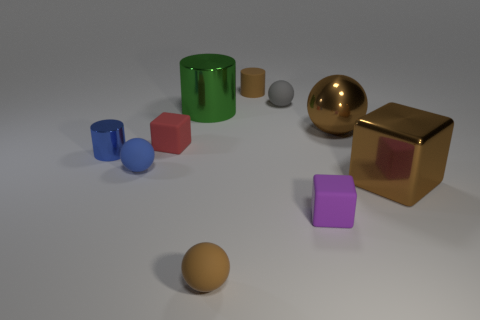Are there fewer big shiny balls in front of the gray rubber thing than large shiny spheres behind the blue cylinder?
Your answer should be compact. No. There is a brown object that is in front of the tiny gray matte object and left of the small gray sphere; what shape is it?
Your answer should be very brief. Sphere. How many other big objects are the same shape as the red object?
Give a very brief answer. 1. There is a red object that is made of the same material as the small gray sphere; what is its size?
Offer a very short reply. Small. Are there more brown rubber objects than tiny blue rubber blocks?
Ensure brevity in your answer.  Yes. There is a tiny cube in front of the tiny blue sphere; what is its color?
Your response must be concise. Purple. There is a thing that is on the left side of the red thing and behind the tiny blue matte thing; how big is it?
Your response must be concise. Small. What number of purple rubber objects have the same size as the green cylinder?
Offer a very short reply. 0. What material is the red object that is the same shape as the purple rubber object?
Make the answer very short. Rubber. Do the tiny red thing and the small metal thing have the same shape?
Your answer should be very brief. No. 